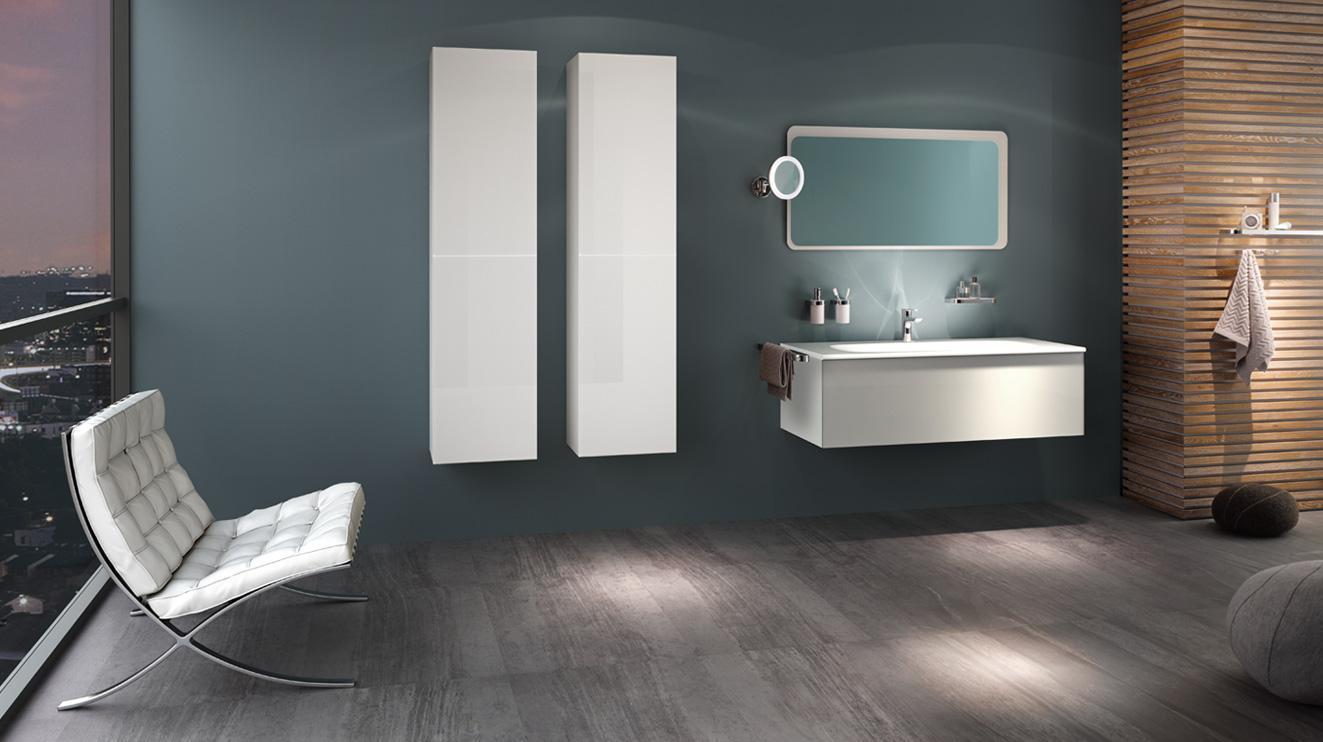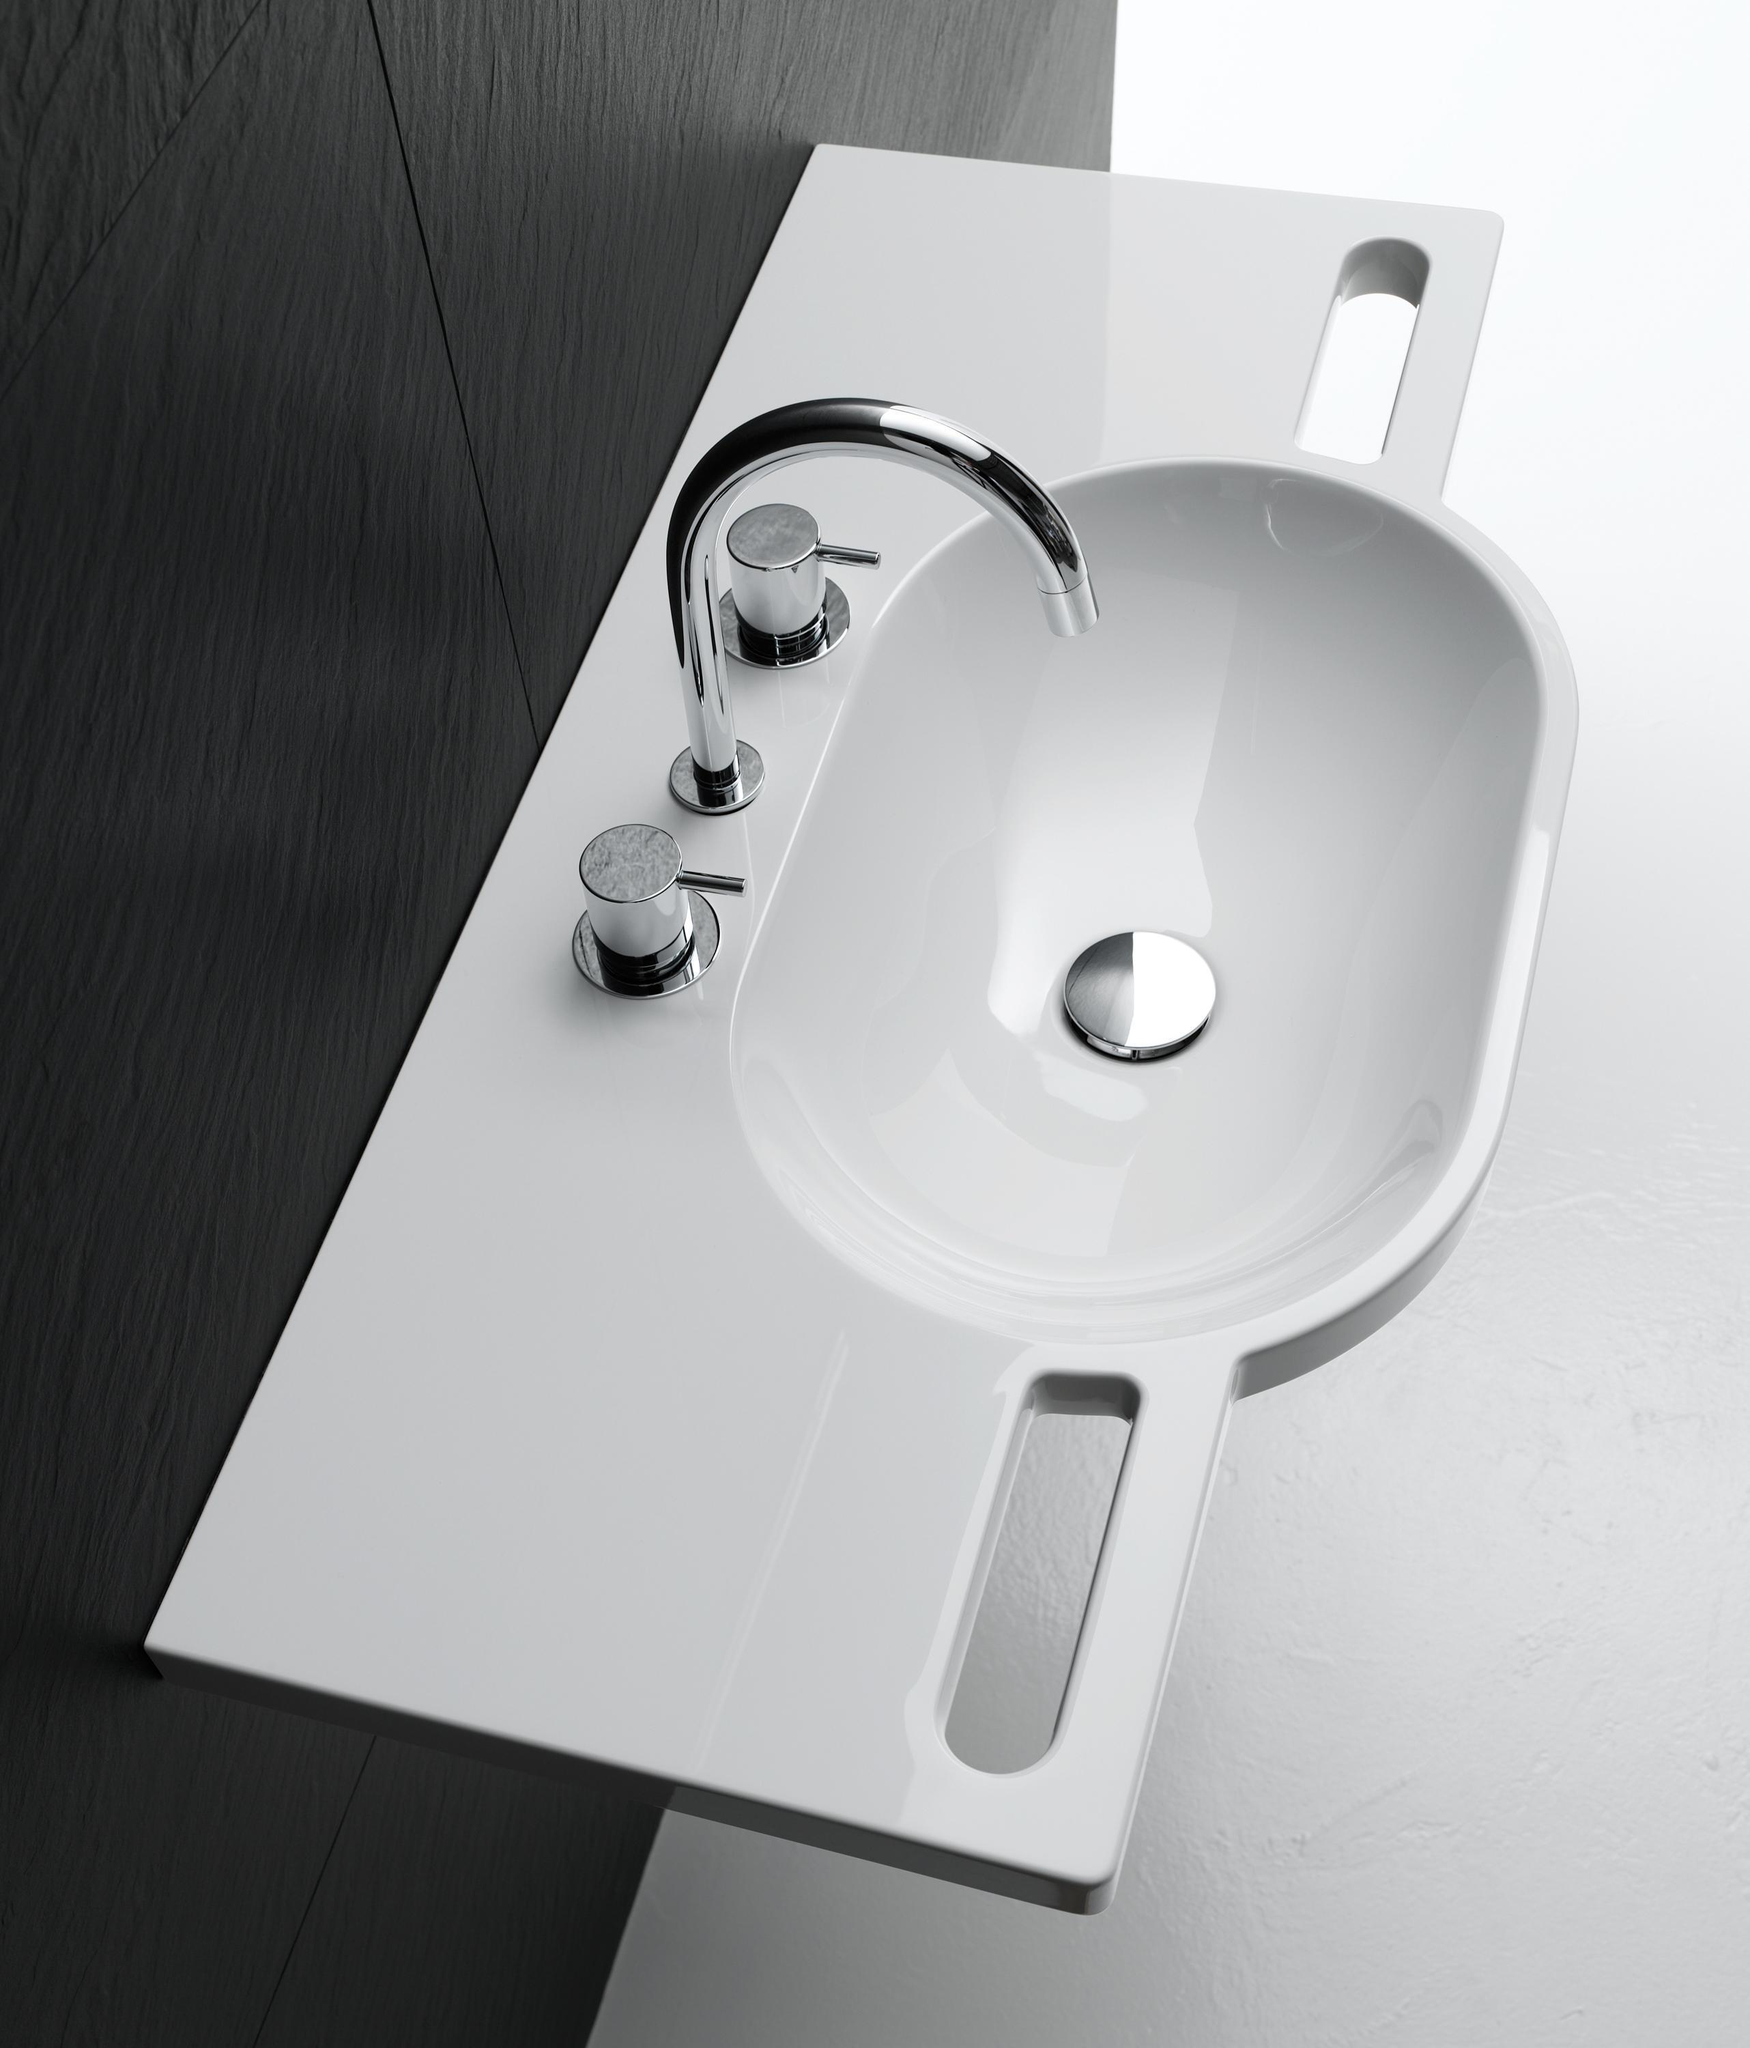The first image is the image on the left, the second image is the image on the right. Analyze the images presented: Is the assertion "One image includes a small round vanity mirror projecting from the wall next to a larger mirror above an oblong sink inset in a narrow, plank-like counter." valid? Answer yes or no. No. 